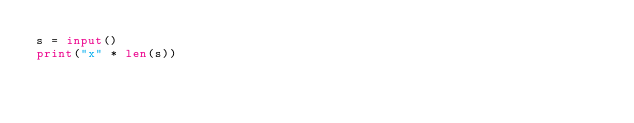<code> <loc_0><loc_0><loc_500><loc_500><_Python_>s = input()
print("x" * len(s))</code> 